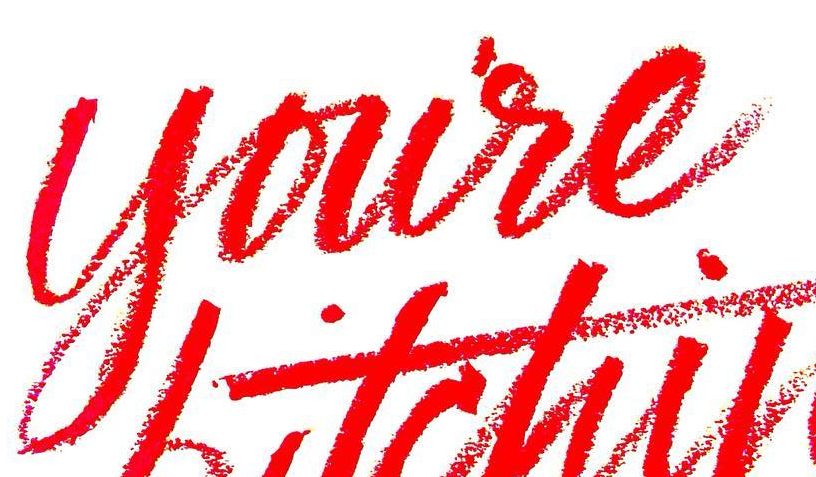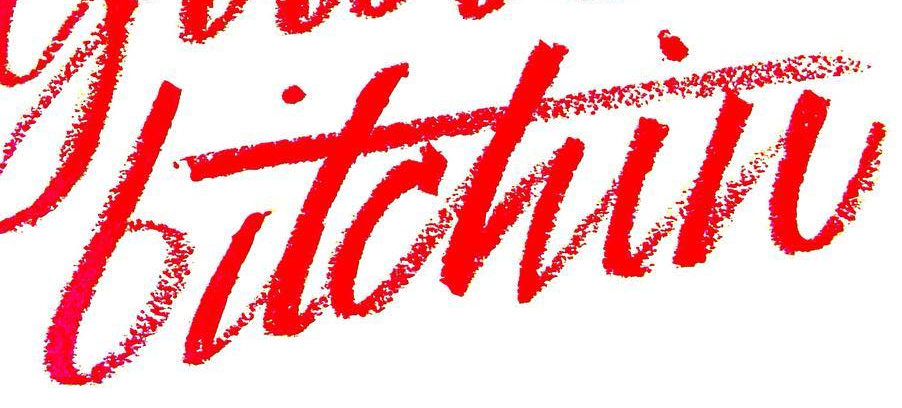Read the text from these images in sequence, separated by a semicolon. youre; bitchin 